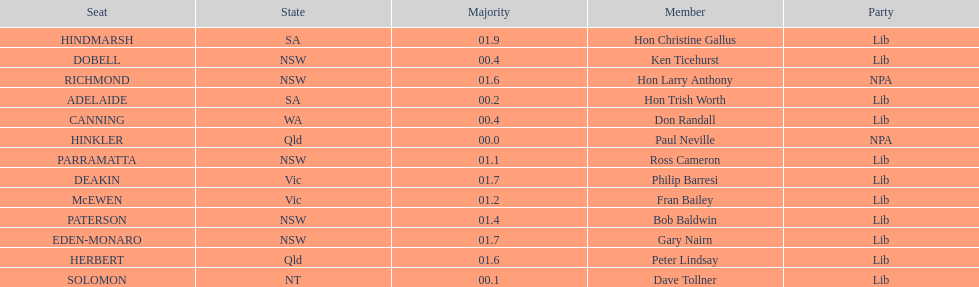Which seats are represented in the electoral system of australia? HINKLER, SOLOMON, ADELAIDE, CANNING, DOBELL, PARRAMATTA, McEWEN, PATERSON, HERBERT, RICHMOND, DEAKIN, EDEN-MONARO, HINDMARSH. What were their majority numbers of both hindmarsh and hinkler? HINKLER, HINDMARSH. Of those two seats, what is the difference in voting majority? 01.9. 